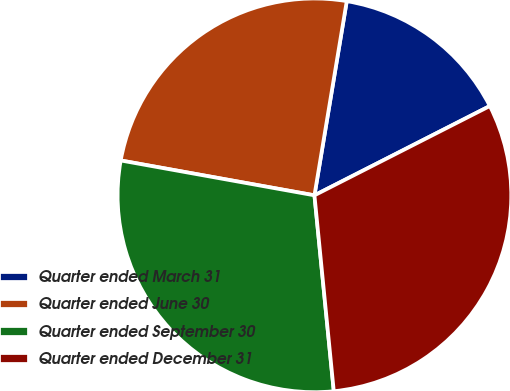<chart> <loc_0><loc_0><loc_500><loc_500><pie_chart><fcel>Quarter ended March 31<fcel>Quarter ended June 30<fcel>Quarter ended September 30<fcel>Quarter ended December 31<nl><fcel>14.88%<fcel>24.79%<fcel>29.4%<fcel>30.93%<nl></chart> 